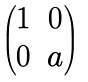<formula> <loc_0><loc_0><loc_500><loc_500>\begin{pmatrix} 1 & 0 \\ 0 & a \end{pmatrix}</formula> 